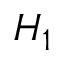Convert formula to latex. <formula><loc_0><loc_0><loc_500><loc_500>H _ { 1 }</formula> 